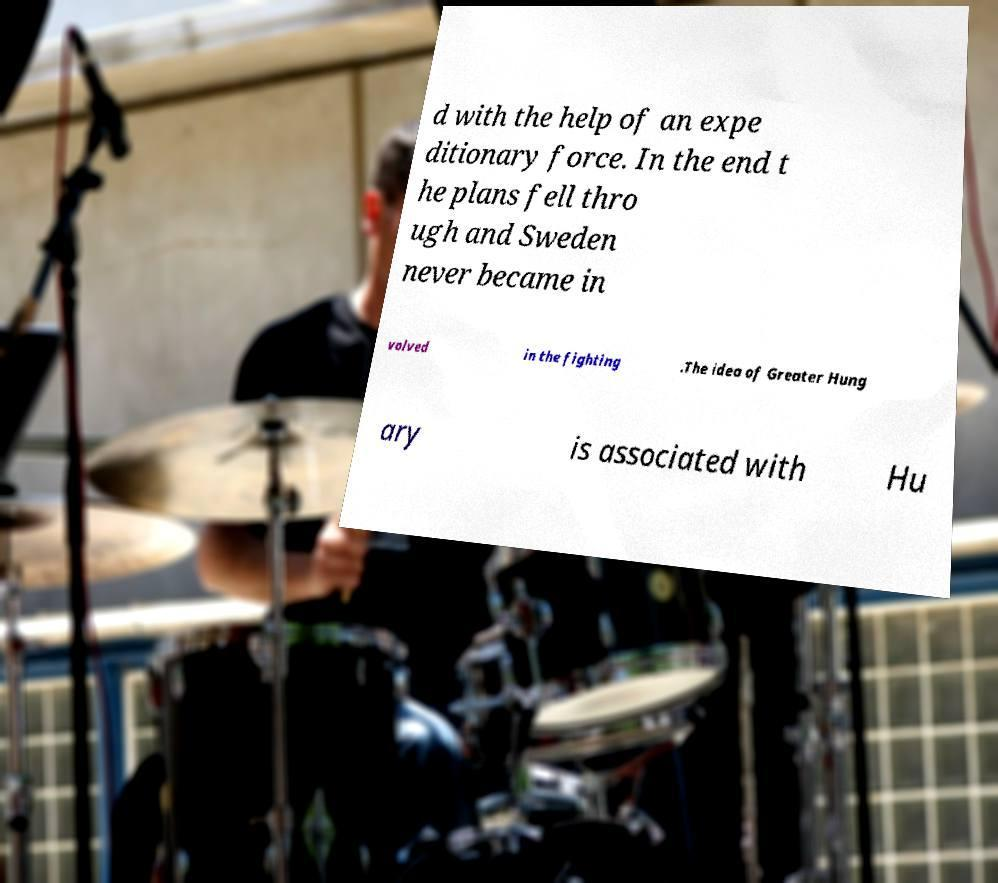Please identify and transcribe the text found in this image. d with the help of an expe ditionary force. In the end t he plans fell thro ugh and Sweden never became in volved in the fighting .The idea of Greater Hung ary is associated with Hu 